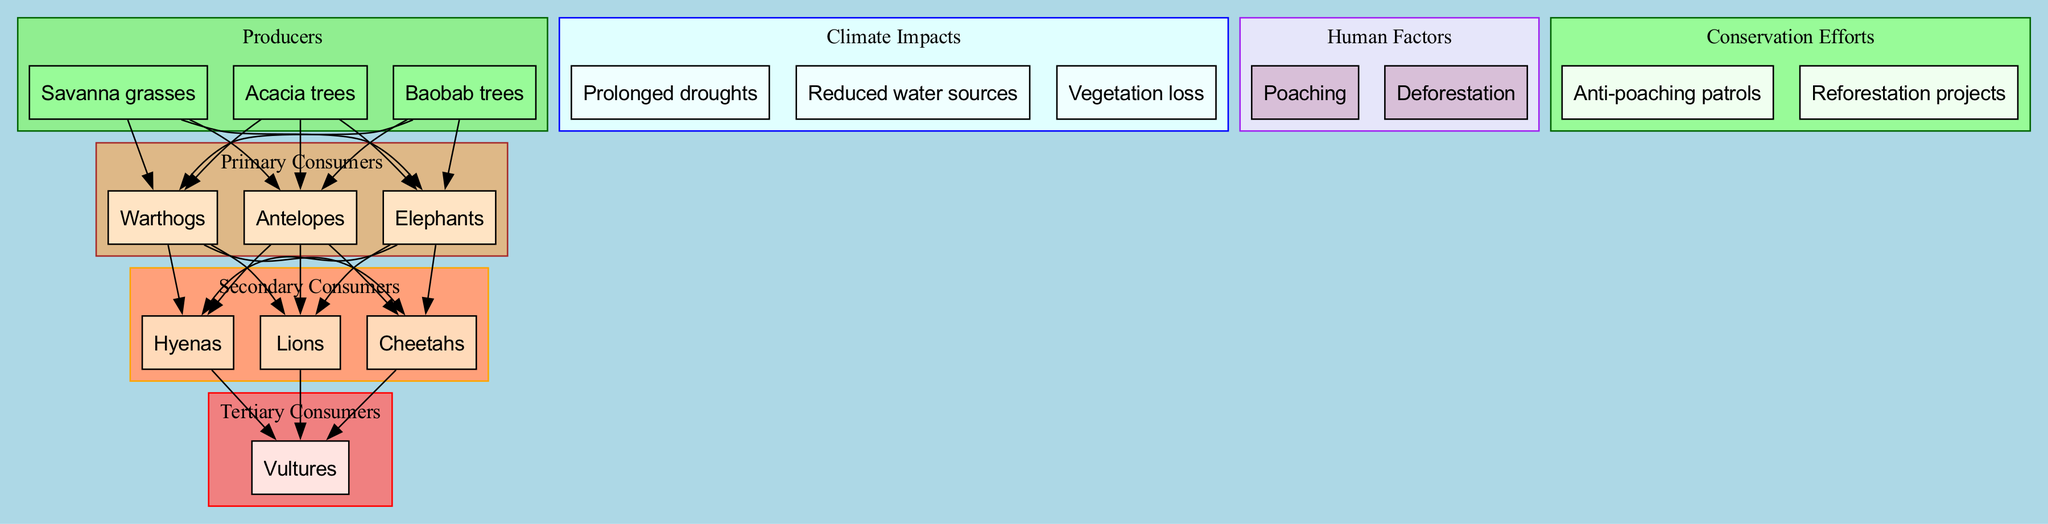What are the producers in the Pendjari National Park food chain? The producers listed in the diagram are Savanna grasses, Acacia trees, and Baobab trees. This information is directly present in the "Producers" cluster in the diagram.
Answer: Savanna grasses, Acacia trees, Baobab trees How many primary consumers are there? The diagram shows three primary consumers: Antelopes, Elephants, and Warthogs. By counting these nodes within the "Primary Consumers" cluster, we arrive at the total.
Answer: 3 Which animal is the tertiary consumer? The only tertiary consumer identified in the diagram is Vultures. This can be found in the "Tertiary Consumers" cluster.
Answer: Vultures What is a climate impact mentioned in the diagram? The diagram lists several climate impacts, including Prolonged droughts, Reduced water sources, and Vegetation loss. This information is provided within the "Climate Impacts" cluster, allowing for a selection of any listed item.
Answer: Prolonged droughts How do prolonged droughts affect primary consumers? Prolonged droughts can lead to reduced water sources, which directly impacts primary consumers by making it harder for them to survive due to a lack of hydration and food sources. The reasoning involves understanding how climate impacts (specifically drought) correlate with the survival needs of primary consumers.
Answer: Reduced water sources What is one conservation effort mentioned? The diagram mentions two conservation efforts: Anti-poaching patrols and Reforestation projects. Either of these efforts is valid as they are explicitly noted in the "Conservation Efforts" cluster.
Answer: Anti-poaching patrols Which secondary consumer is at the top of the food chain? The secondary consumers listed are Lions, Cheetahs, and Hyenas. Among these, Lions are generally considered to be apex predators, which makes them the top secondary consumer in the food chain context.
Answer: Lions How do human factors impact the food chain? Human factors such as Poaching and Deforestation contribute negatively to the food chain by threatening the populations of both consumers and producers within the ecosystem. To answer this, one can trace how these factors could lead to decreases in these populations, ultimately affecting the stability of the food chain.
Answer: Poaching What happens if deforestation continues? Continued deforestation will likely lead to vegetation loss, as trees are removed, impacting producers directly. This affects the entire food chain because it disrupts the source of energy and habitat for various consumers. By understanding the relationships in the diagram, we see that without vegetation, primary consumers would struggle to find food, ultimately affecting secondary consumers and so on.
Answer: Vegetation loss 